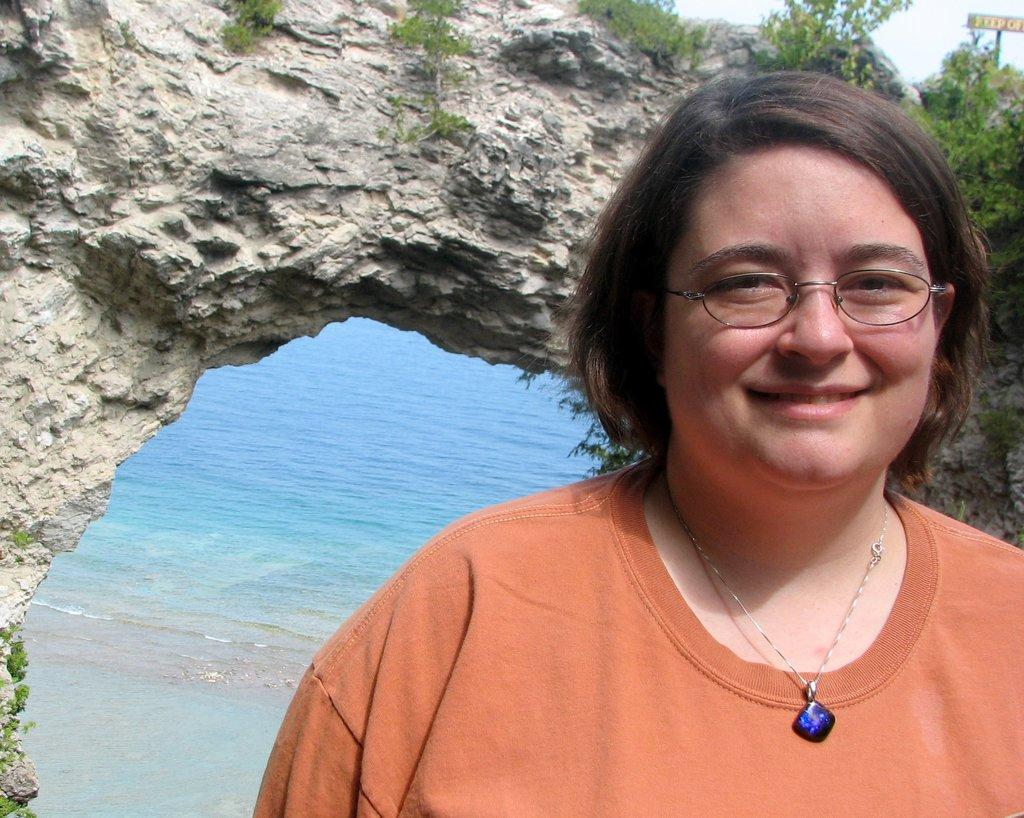What is the main subject in the foreground of the picture? There is a woman in the foreground of the picture. Can you describe the woman's appearance? The woman is wearing spectacles and an orange t-shirt. What can be seen in the center of the image? There are plants and a rock in the center of the image. What is visible in the background of the image? There is water visible in the background of the image. How many cattle can be seen grazing in the image? There are no cattle present in the image. What type of mint is growing near the rock in the center of the image? There is no mint visible in the image; only plants and a rock are present in the center. 